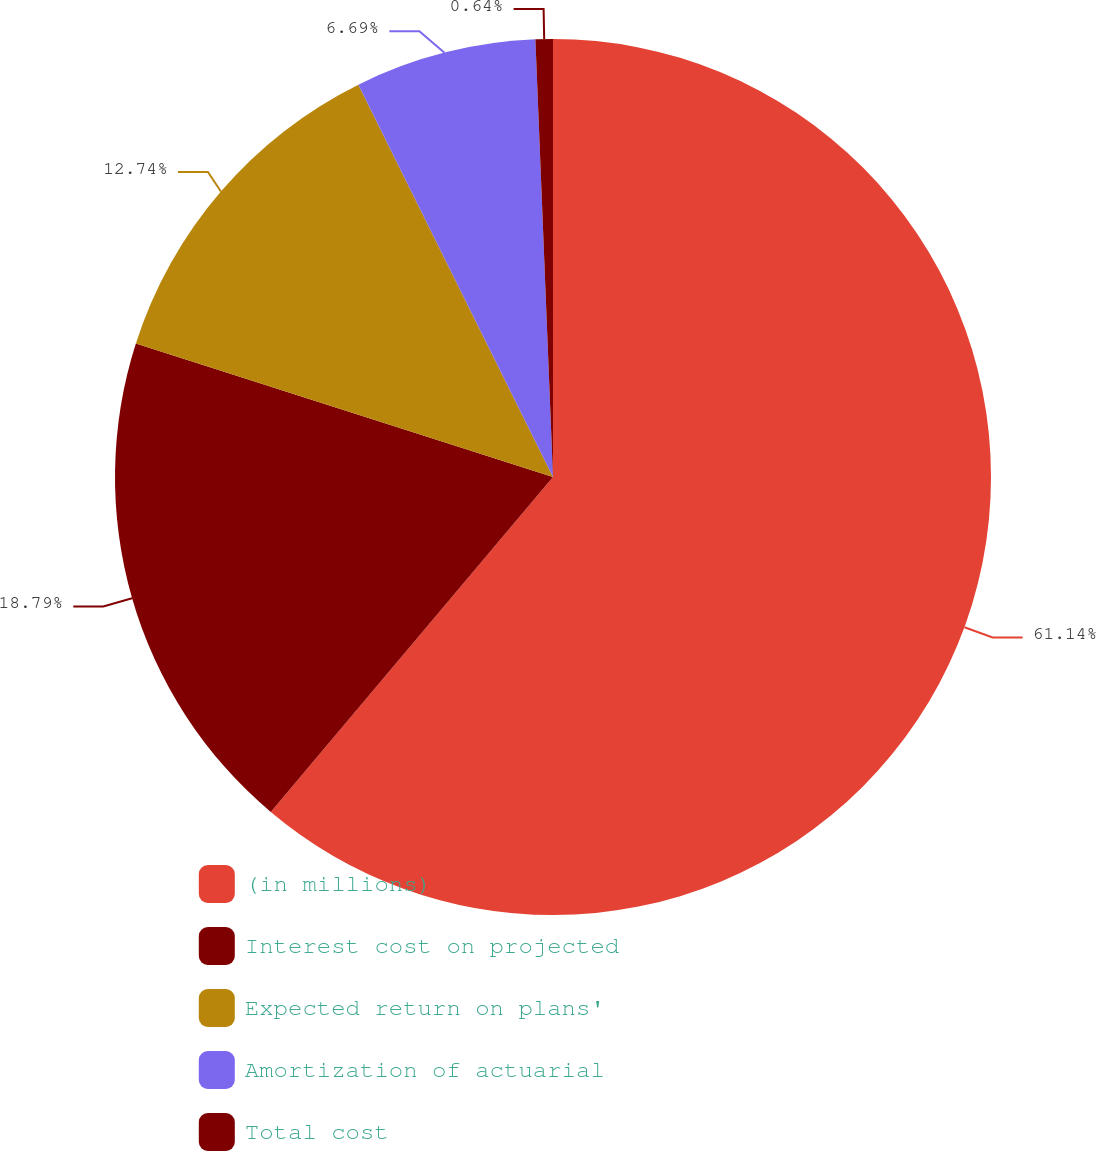Convert chart. <chart><loc_0><loc_0><loc_500><loc_500><pie_chart><fcel>(in millions)<fcel>Interest cost on projected<fcel>Expected return on plans'<fcel>Amortization of actuarial<fcel>Total cost<nl><fcel>61.15%<fcel>18.79%<fcel>12.74%<fcel>6.69%<fcel>0.64%<nl></chart> 